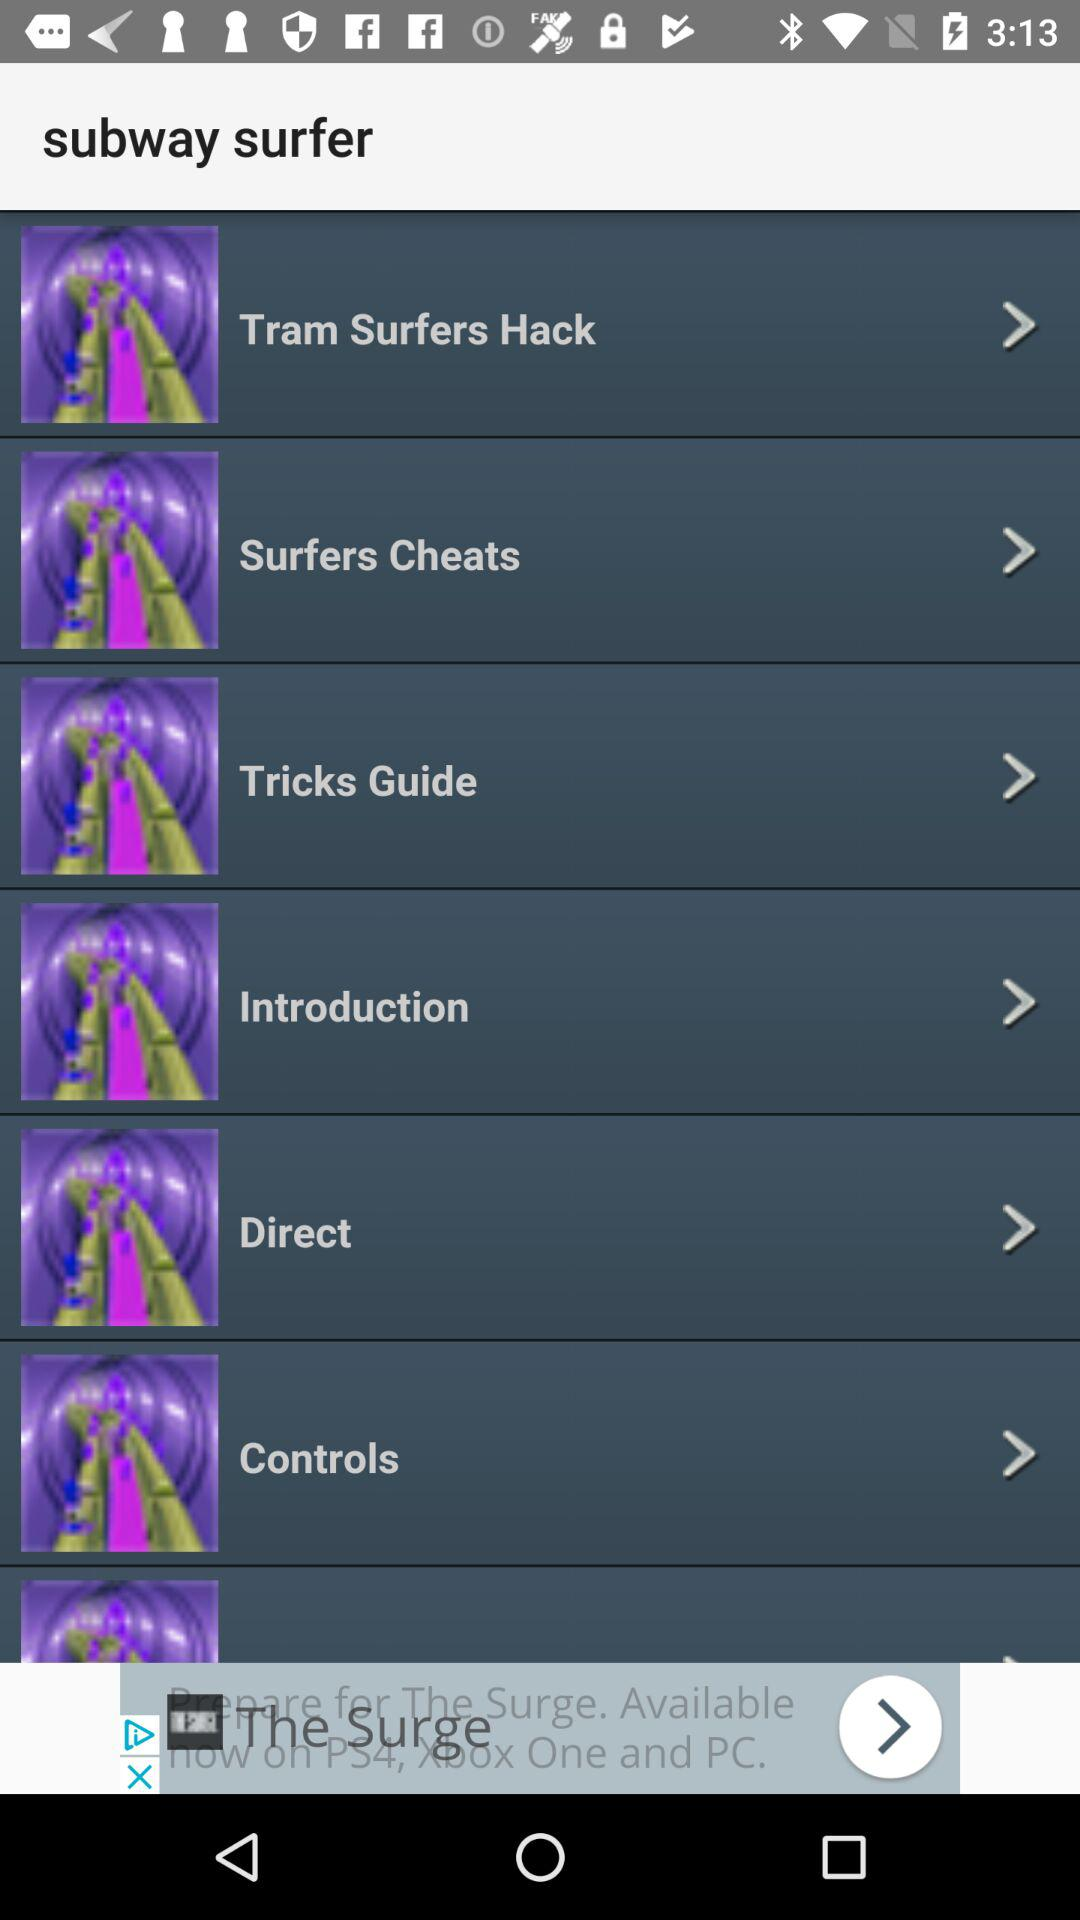What is the name of the application? The name of the application is "subway surfer". 